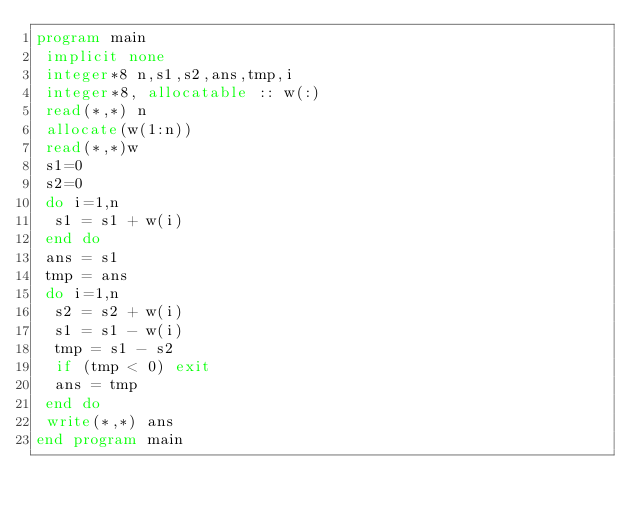Convert code to text. <code><loc_0><loc_0><loc_500><loc_500><_FORTRAN_>program main
 implicit none
 integer*8 n,s1,s2,ans,tmp,i
 integer*8, allocatable :: w(:)
 read(*,*) n
 allocate(w(1:n))
 read(*,*)w
 s1=0
 s2=0
 do i=1,n
  s1 = s1 + w(i)
 end do
 ans = s1
 tmp = ans
 do i=1,n
  s2 = s2 + w(i)
  s1 = s1 - w(i)
  tmp = s1 - s2
  if (tmp < 0) exit
  ans = tmp
 end do
 write(*,*) ans
end program main</code> 